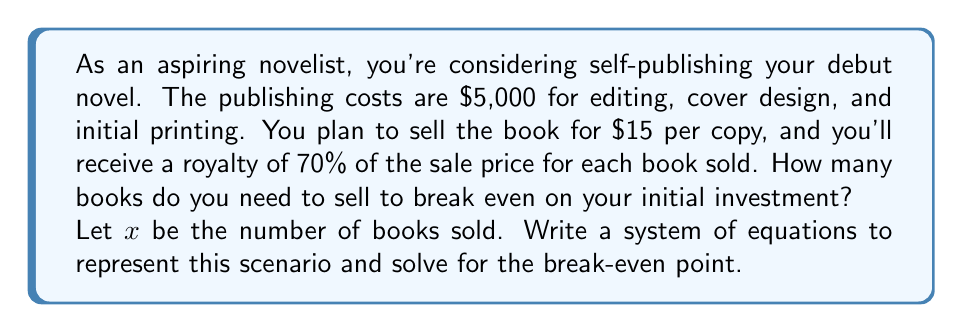Show me your answer to this math problem. Let's approach this problem step-by-step:

1) First, let's define our variables:
   $x$ = number of books sold
   $R$ = total revenue
   $C$ = total cost

2) We can write two equations:

   Revenue equation: $R = 15x \cdot 0.70$
   (Each book sells for $15, and you receive 70% of that)

   Cost equation: $C = 5000 + 15x \cdot 0.30$
   (Initial cost of $5000, plus 30% of the sale price goes to the retailer for each book)

3) At the break-even point, revenue equals cost:

   $R = C$

4) Substituting our equations:

   $15x \cdot 0.70 = 5000 + 15x \cdot 0.30$

5) Simplify:

   $10.50x = 5000 + 4.50x$

6) Subtract $4.50x$ from both sides:

   $6x = 5000$

7) Divide both sides by 6:

   $x = \frac{5000}{6} \approx 833.33$

8) Since we can't sell a fraction of a book, we round up to the nearest whole number.

Therefore, you need to sell 834 books to break even.
Answer: 834 books 